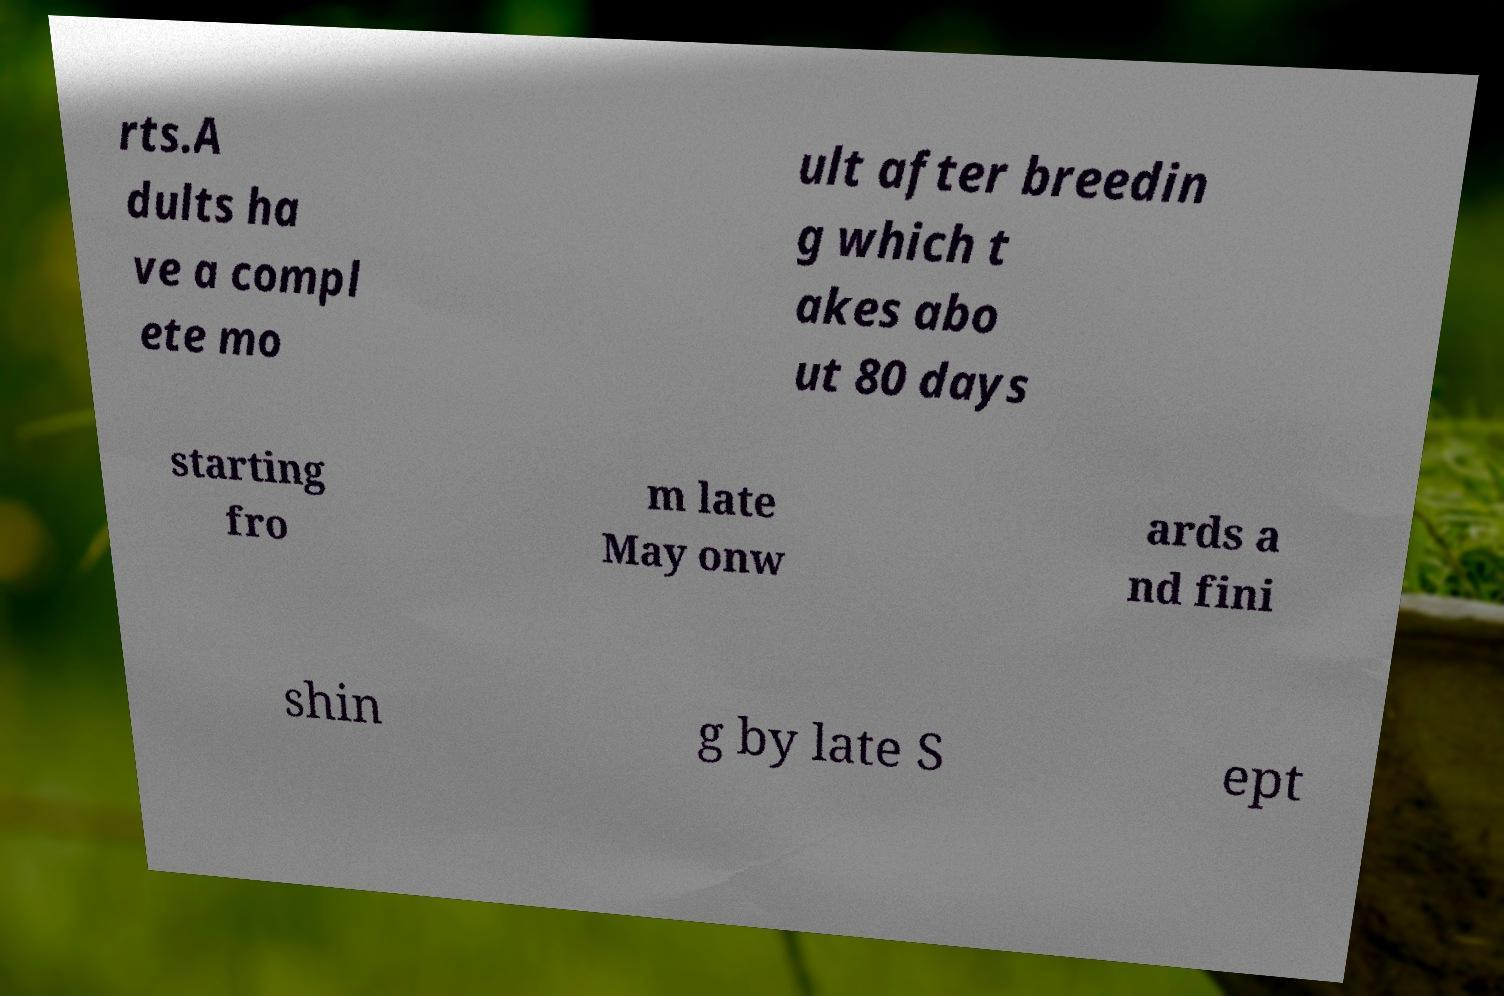Please read and relay the text visible in this image. What does it say? rts.A dults ha ve a compl ete mo ult after breedin g which t akes abo ut 80 days starting fro m late May onw ards a nd fini shin g by late S ept 